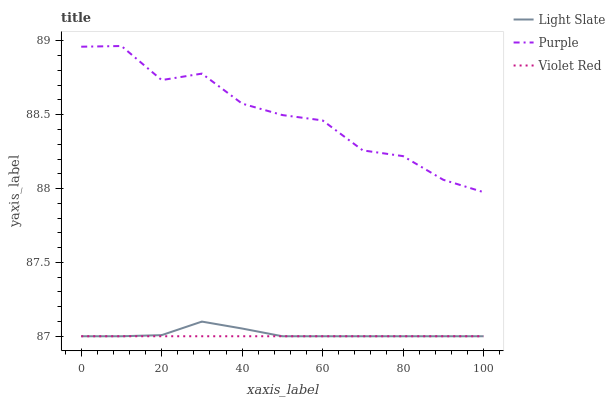Does Violet Red have the minimum area under the curve?
Answer yes or no. Yes. Does Purple have the maximum area under the curve?
Answer yes or no. Yes. Does Purple have the minimum area under the curve?
Answer yes or no. No. Does Violet Red have the maximum area under the curve?
Answer yes or no. No. Is Violet Red the smoothest?
Answer yes or no. Yes. Is Purple the roughest?
Answer yes or no. Yes. Is Purple the smoothest?
Answer yes or no. No. Is Violet Red the roughest?
Answer yes or no. No. Does Purple have the lowest value?
Answer yes or no. No. Does Violet Red have the highest value?
Answer yes or no. No. Is Light Slate less than Purple?
Answer yes or no. Yes. Is Purple greater than Light Slate?
Answer yes or no. Yes. Does Light Slate intersect Purple?
Answer yes or no. No. 